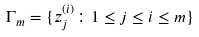<formula> <loc_0><loc_0><loc_500><loc_500>\Gamma _ { m } = \{ z _ { j } ^ { ( i ) } \colon 1 \leq j \leq i \leq m \}</formula> 